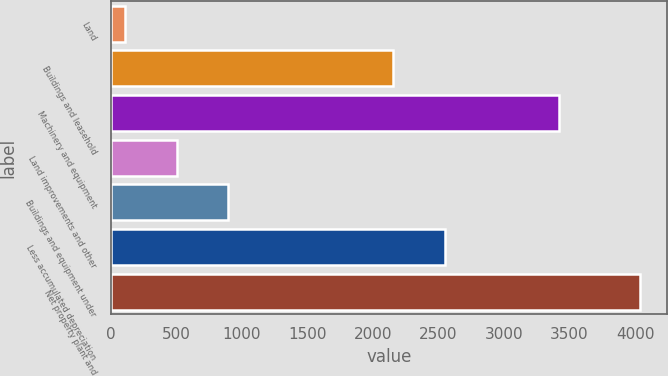Convert chart. <chart><loc_0><loc_0><loc_500><loc_500><bar_chart><fcel>Land<fcel>Buildings and leasehold<fcel>Machinery and equipment<fcel>Land improvements and other<fcel>Buildings and equipment under<fcel>Less accumulated depreciation<fcel>Net property plant and<nl><fcel>111<fcel>2154<fcel>3419<fcel>503.7<fcel>896.4<fcel>2546.7<fcel>4038<nl></chart> 